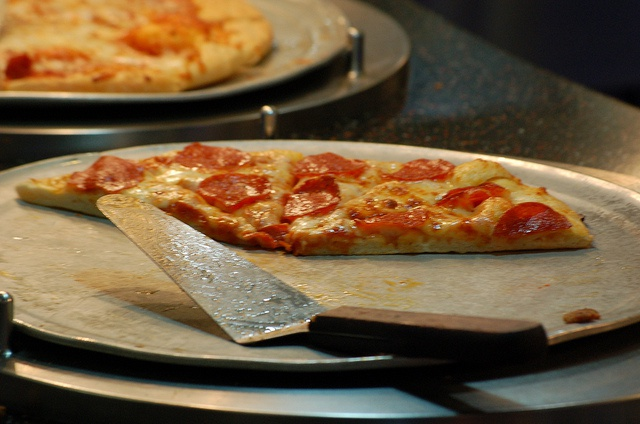Describe the objects in this image and their specific colors. I can see pizza in tan, red, and maroon tones, pizza in tan, orange, and red tones, and knife in tan, black, darkgray, and gray tones in this image. 